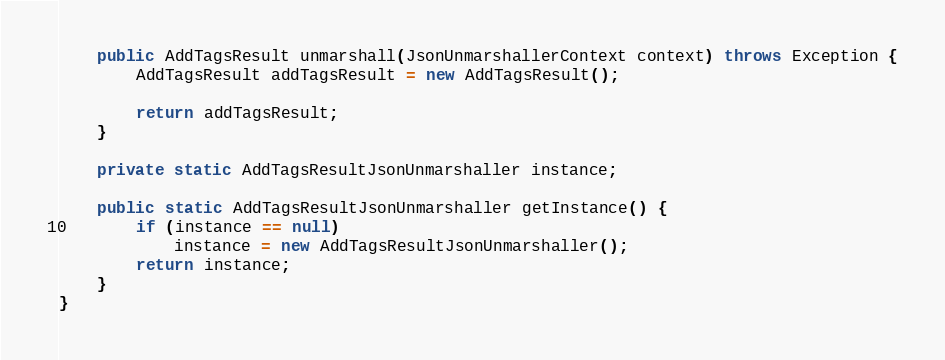Convert code to text. <code><loc_0><loc_0><loc_500><loc_500><_Java_>
    public AddTagsResult unmarshall(JsonUnmarshallerContext context) throws Exception {
        AddTagsResult addTagsResult = new AddTagsResult();

        return addTagsResult;
    }

    private static AddTagsResultJsonUnmarshaller instance;

    public static AddTagsResultJsonUnmarshaller getInstance() {
        if (instance == null)
            instance = new AddTagsResultJsonUnmarshaller();
        return instance;
    }
}
</code> 